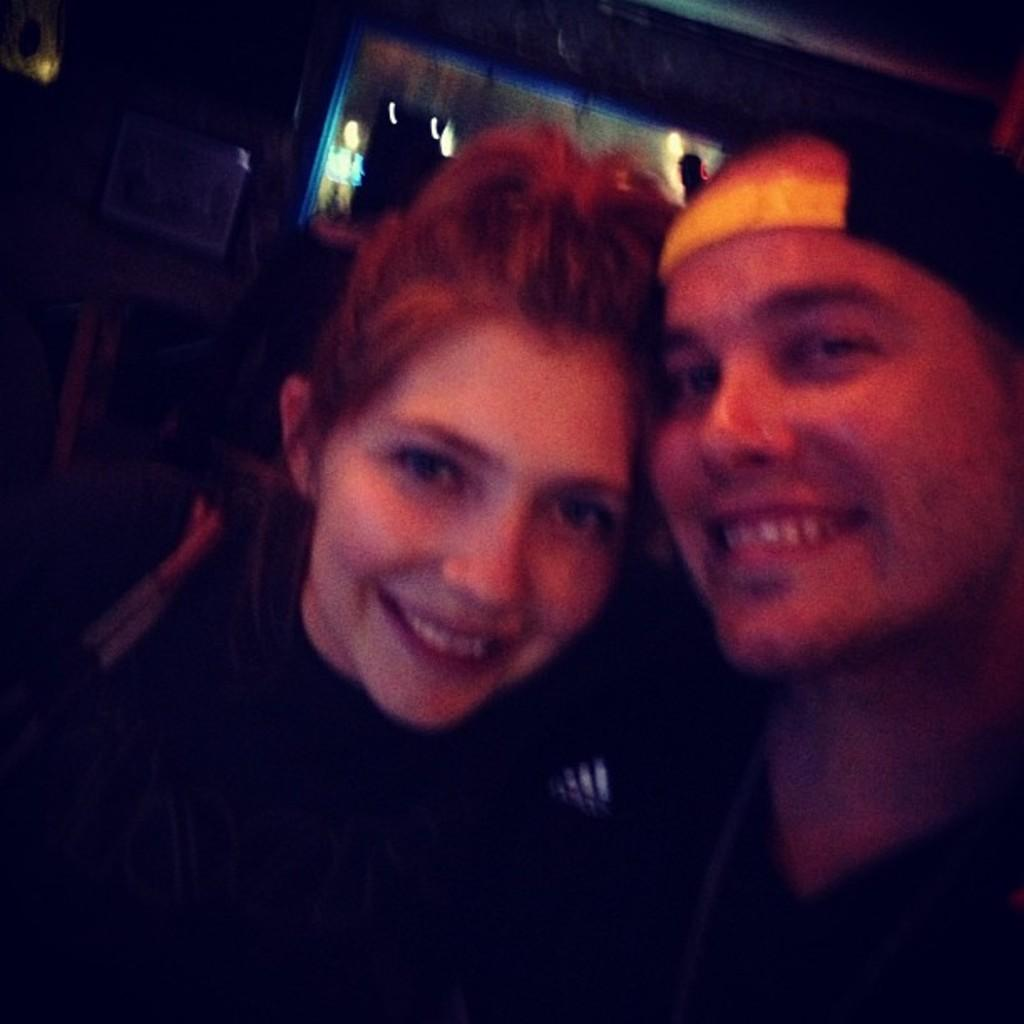How many people are present in the image? There are two people in the image, a man and a woman. What are the expressions on their faces? Both the man and the woman are smiling in the image. Can you describe the background of the image? The background of the image is blurred and dark. What type of jam is being spread on the stick in the image? There is no jam or stick present in the image. What kind of sail can be seen in the background of the image? There is no sail visible in the image; the background is blurred and dark. 